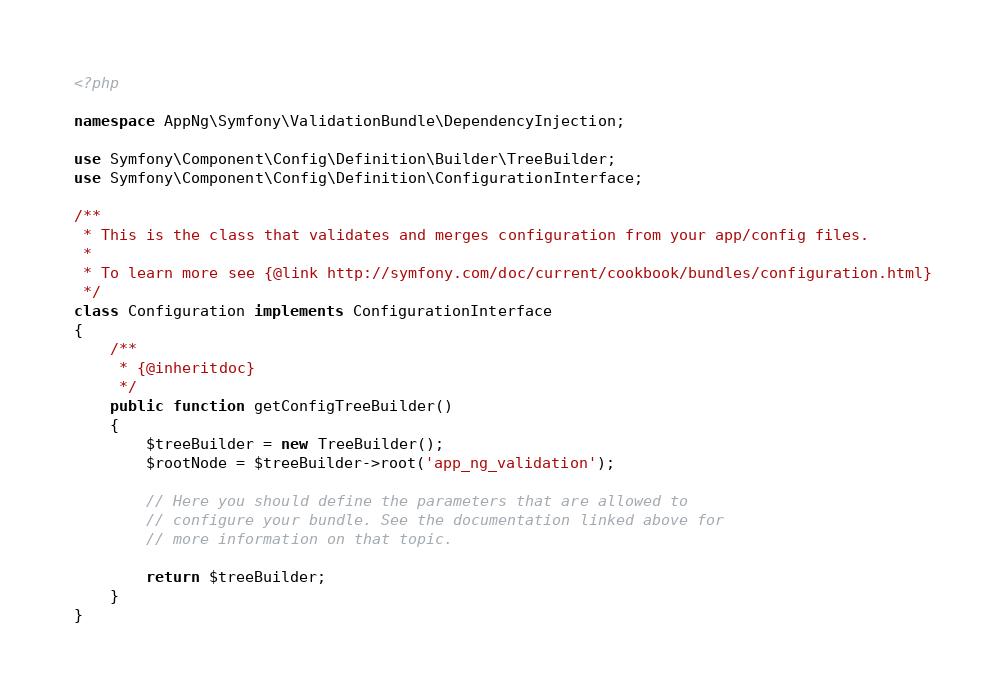Convert code to text. <code><loc_0><loc_0><loc_500><loc_500><_PHP_><?php

namespace AppNg\Symfony\ValidationBundle\DependencyInjection;

use Symfony\Component\Config\Definition\Builder\TreeBuilder;
use Symfony\Component\Config\Definition\ConfigurationInterface;

/**
 * This is the class that validates and merges configuration from your app/config files.
 *
 * To learn more see {@link http://symfony.com/doc/current/cookbook/bundles/configuration.html}
 */
class Configuration implements ConfigurationInterface
{
    /**
     * {@inheritdoc}
     */
    public function getConfigTreeBuilder()
    {
        $treeBuilder = new TreeBuilder();
        $rootNode = $treeBuilder->root('app_ng_validation');

        // Here you should define the parameters that are allowed to
        // configure your bundle. See the documentation linked above for
        // more information on that topic.

        return $treeBuilder;
    }
}
</code> 